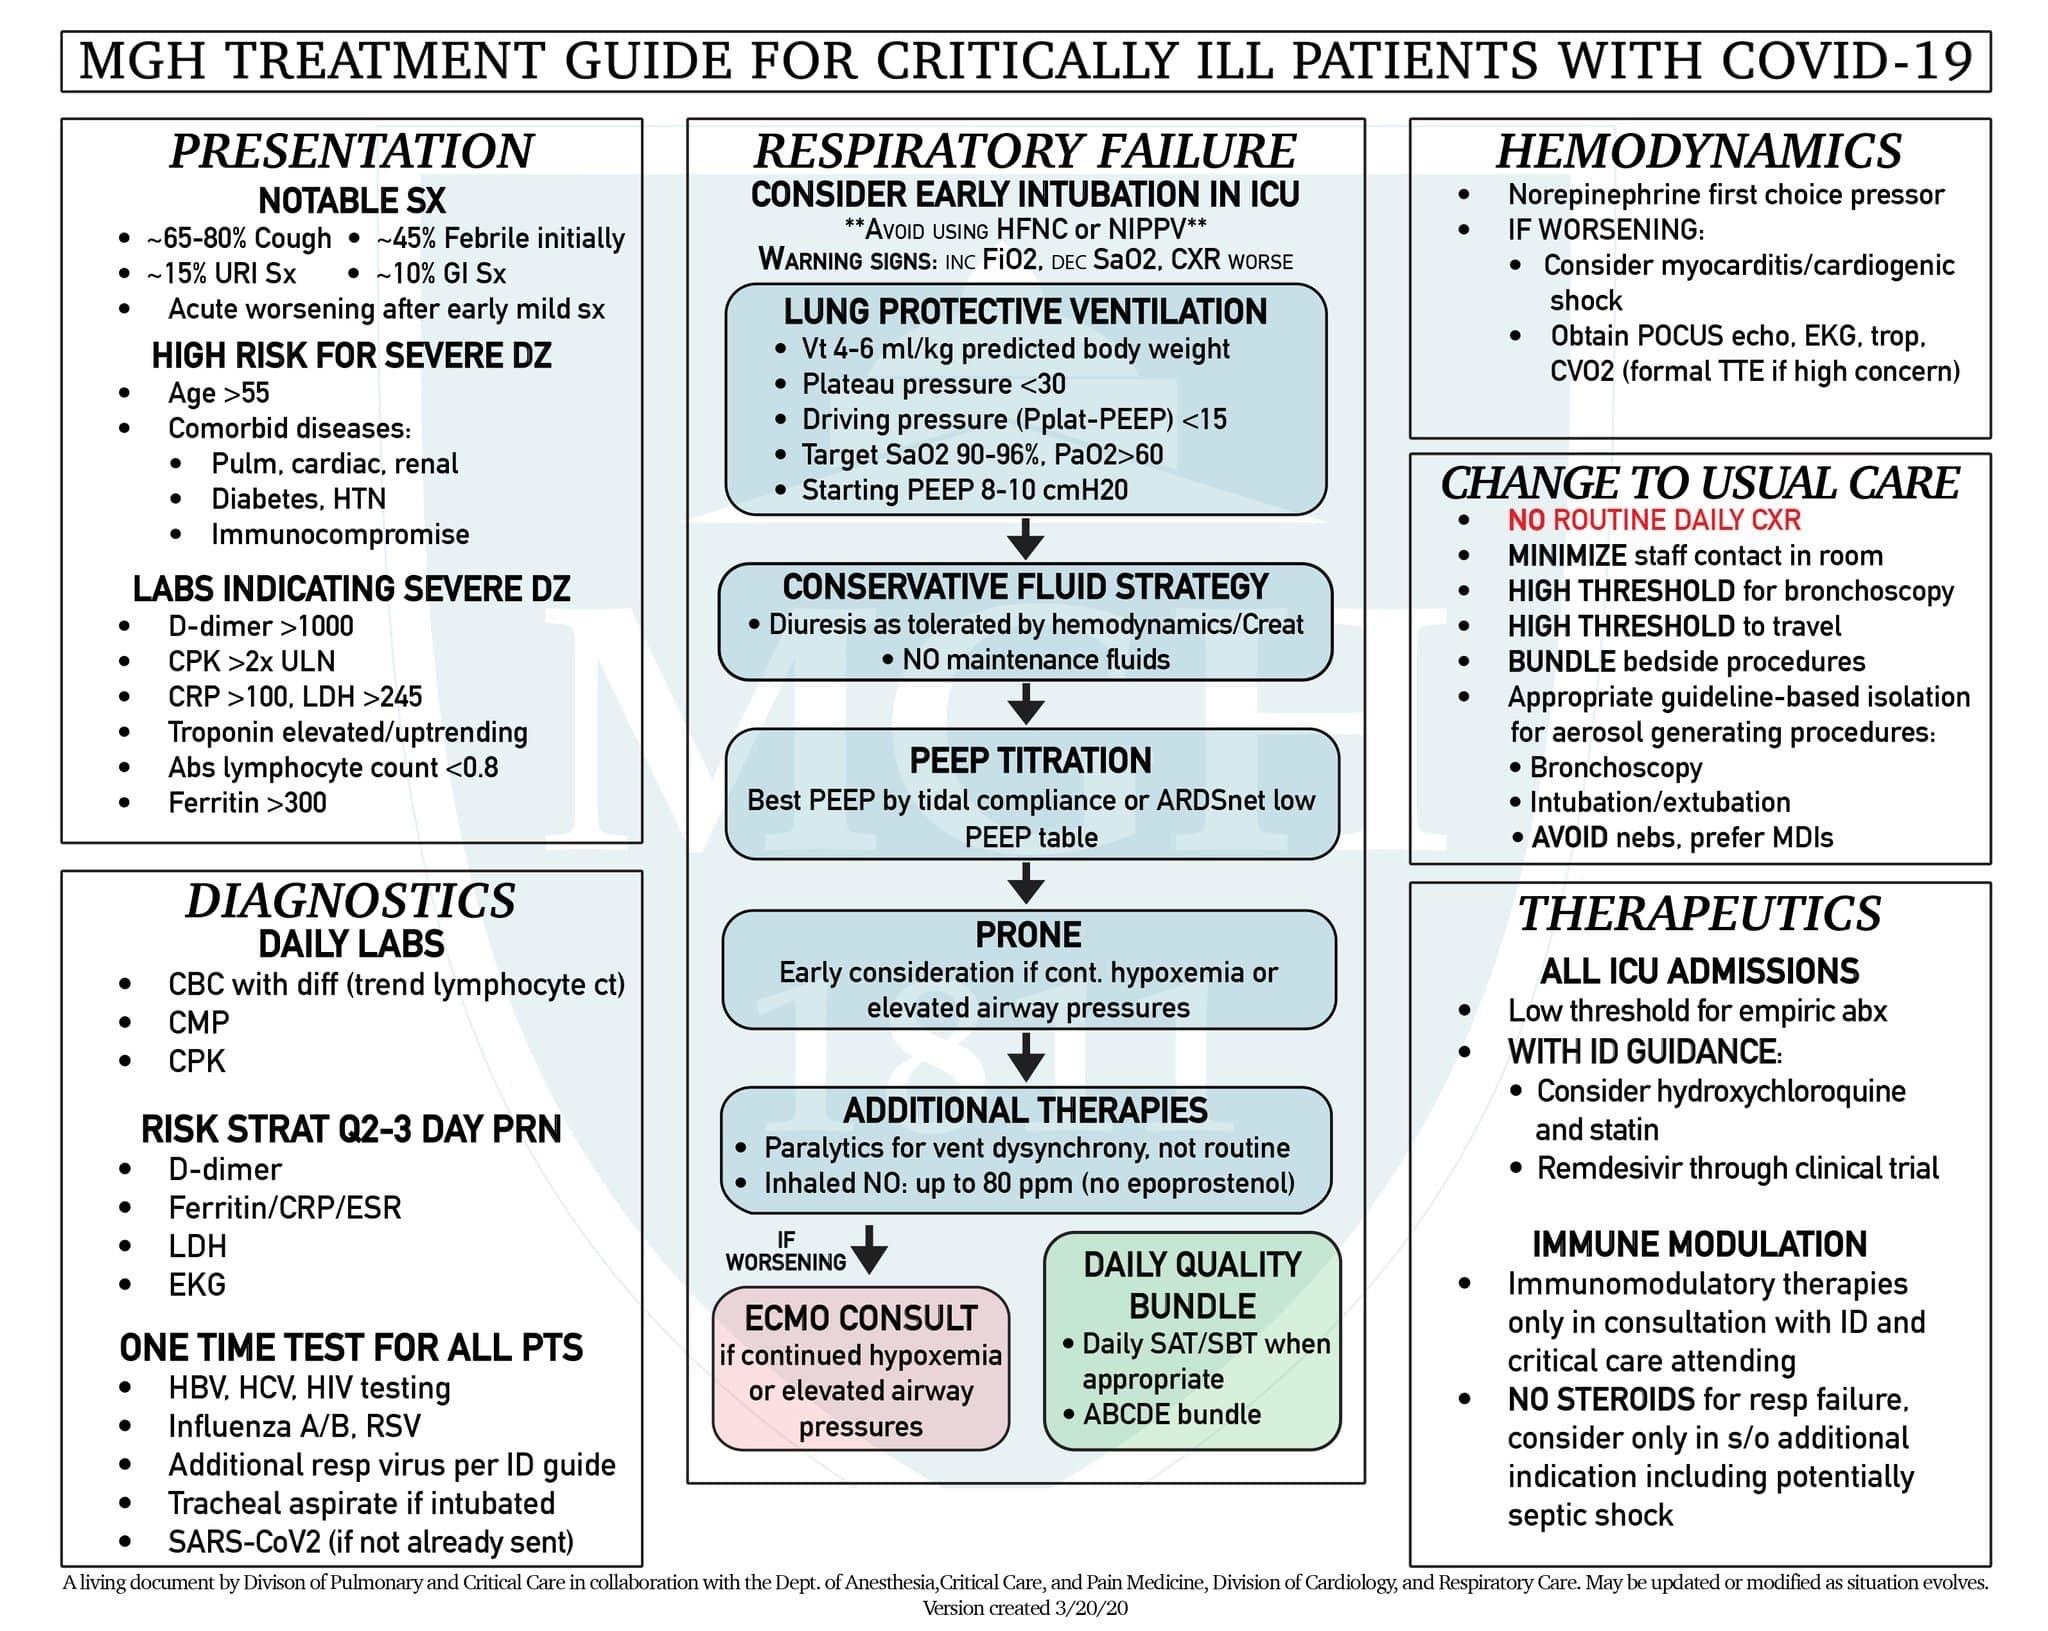Give some essential details in this illustration. In the event of respiratory failure and if the condition worsens after receiving additional therapies, it is necessary to seek consultation from an ECMO (Extracorporeal Membrane Oxygenation) specialist. The Conservative fluid strategy's next step is PEEP titration. After performing a PEEP titration, the next step is to proceed with a PRONE test. After lung protective ventilation, the next step is to adopt a conservative fluid strategy. The last subpoint under the category of 'lung protective ventilation' is the use of starting positive end-expiratory pressure (PEEP) at 8-10 cmH2O. 